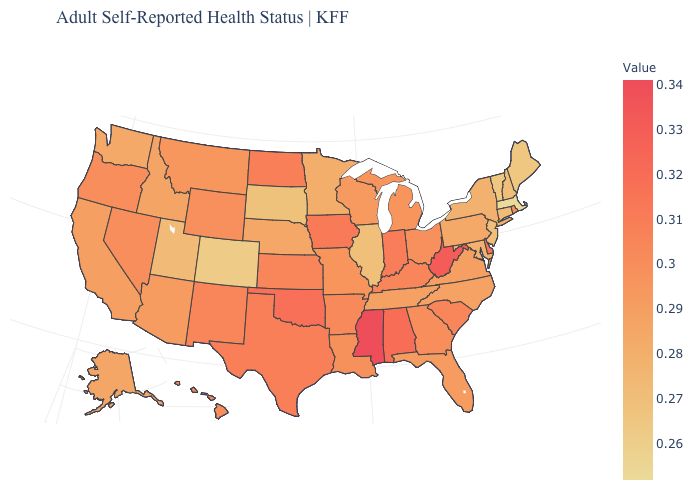Does Colorado have the lowest value in the West?
Concise answer only. Yes. Among the states that border Idaho , which have the highest value?
Short answer required. Nevada, Oregon. Which states have the highest value in the USA?
Answer briefly. Mississippi. Among the states that border New Jersey , which have the lowest value?
Give a very brief answer. New York. 